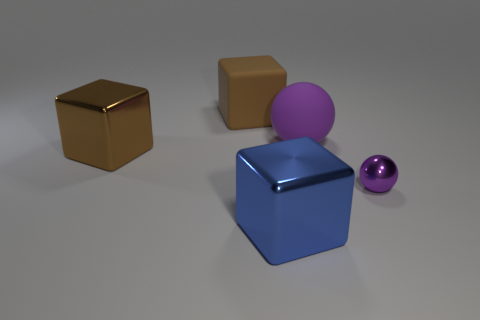What number of large blue cubes are right of the large brown object in front of the brown rubber cube?
Your answer should be very brief. 1. There is another thing that is the same color as the tiny thing; what size is it?
Ensure brevity in your answer.  Large. How many things are large brown things or things left of the small purple sphere?
Give a very brief answer. 4. Is there another object made of the same material as the small purple thing?
Offer a very short reply. Yes. What number of big things are both behind the brown metallic thing and right of the brown rubber cube?
Your answer should be compact. 1. What is the large block right of the matte block made of?
Keep it short and to the point. Metal. The blue thing that is made of the same material as the tiny purple thing is what size?
Your answer should be very brief. Large. There is a purple metallic sphere; are there any spheres in front of it?
Give a very brief answer. No. What size is the blue thing that is the same shape as the brown metal thing?
Give a very brief answer. Large. There is a matte ball; is it the same color as the small shiny object right of the big purple rubber thing?
Offer a very short reply. Yes. 